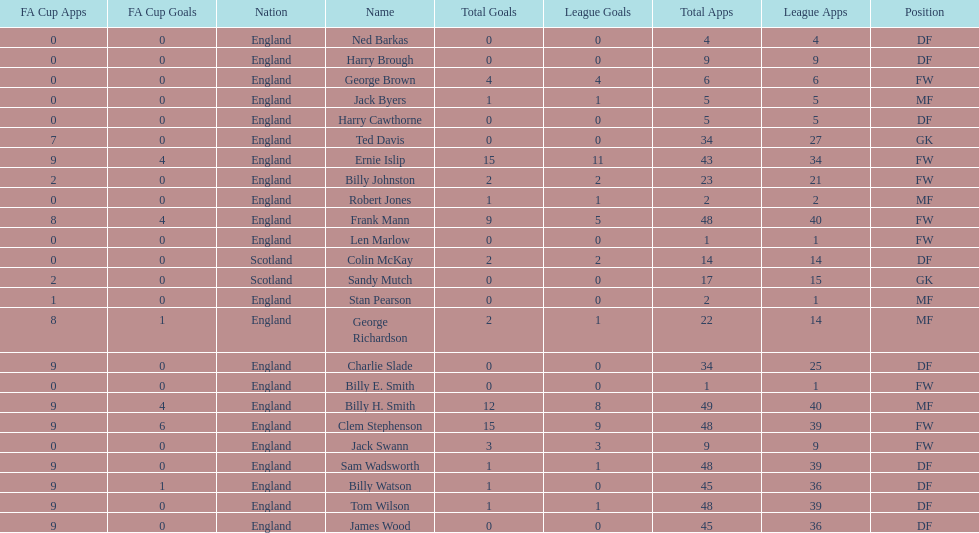Average number of goals scored by players from scotland 1. 